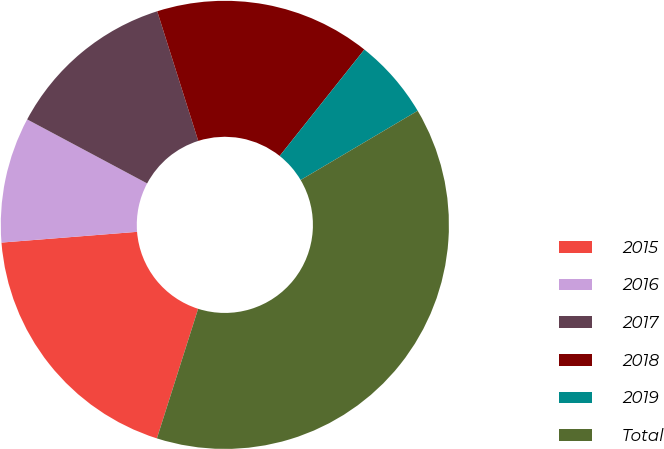<chart> <loc_0><loc_0><loc_500><loc_500><pie_chart><fcel>2015<fcel>2016<fcel>2017<fcel>2018<fcel>2019<fcel>Total<nl><fcel>18.84%<fcel>9.06%<fcel>12.32%<fcel>15.58%<fcel>5.8%<fcel>38.41%<nl></chart> 